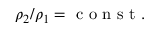<formula> <loc_0><loc_0><loc_500><loc_500>\rho _ { 2 } / \rho _ { 1 } = c o n s t .</formula> 